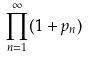Convert formula to latex. <formula><loc_0><loc_0><loc_500><loc_500>\prod _ { n = 1 } ^ { \infty } ( 1 + p _ { n } )</formula> 